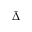Convert formula to latex. <formula><loc_0><loc_0><loc_500><loc_500>\bar { \Delta }</formula> 